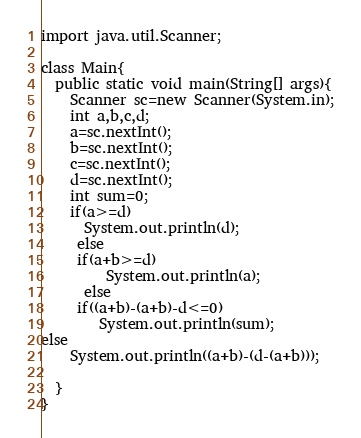Convert code to text. <code><loc_0><loc_0><loc_500><loc_500><_Java_>import java.util.Scanner;

class Main{
  public static void main(String[] args){
    Scanner sc=new Scanner(System.in);
    int a,b,c,d;
    a=sc.nextInt();
    b=sc.nextInt();
    c=sc.nextInt();
    d=sc.nextInt();
    int sum=0;
    if(a>=d)
      System.out.println(d);
     else
     if(a+b>=d)
         System.out.println(a);
      else
     if((a+b)-(a+b)-d<=0)
        System.out.println(sum);
else
    System.out.println((a+b)-(d-(a+b)));
    
  }
}</code> 